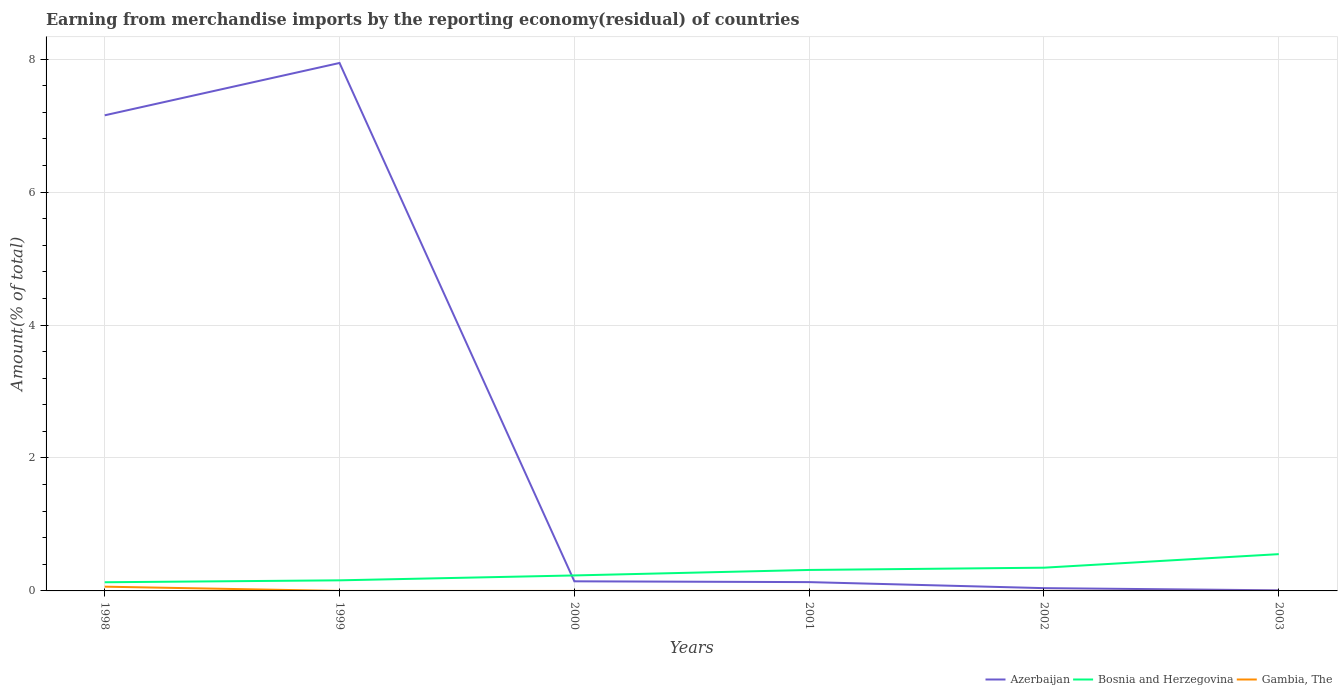How many different coloured lines are there?
Your answer should be compact. 3. Does the line corresponding to Azerbaijan intersect with the line corresponding to Bosnia and Herzegovina?
Offer a very short reply. Yes. Across all years, what is the maximum percentage of amount earned from merchandise imports in Azerbaijan?
Make the answer very short. 0.01. What is the total percentage of amount earned from merchandise imports in Gambia, The in the graph?
Your response must be concise. 8.75182859258105e-9. What is the difference between the highest and the second highest percentage of amount earned from merchandise imports in Gambia, The?
Your answer should be very brief. 0.06. What is the difference between the highest and the lowest percentage of amount earned from merchandise imports in Azerbaijan?
Ensure brevity in your answer.  2. Is the percentage of amount earned from merchandise imports in Azerbaijan strictly greater than the percentage of amount earned from merchandise imports in Gambia, The over the years?
Ensure brevity in your answer.  No. How many lines are there?
Your answer should be very brief. 3. What is the difference between two consecutive major ticks on the Y-axis?
Give a very brief answer. 2. Where does the legend appear in the graph?
Make the answer very short. Bottom right. How are the legend labels stacked?
Make the answer very short. Horizontal. What is the title of the graph?
Offer a terse response. Earning from merchandise imports by the reporting economy(residual) of countries. What is the label or title of the Y-axis?
Your answer should be compact. Amount(% of total). What is the Amount(% of total) of Azerbaijan in 1998?
Give a very brief answer. 7.16. What is the Amount(% of total) of Bosnia and Herzegovina in 1998?
Offer a terse response. 0.13. What is the Amount(% of total) of Gambia, The in 1998?
Provide a short and direct response. 0.06. What is the Amount(% of total) of Azerbaijan in 1999?
Provide a succinct answer. 7.94. What is the Amount(% of total) in Bosnia and Herzegovina in 1999?
Offer a very short reply. 0.16. What is the Amount(% of total) of Gambia, The in 1999?
Your response must be concise. 0. What is the Amount(% of total) of Azerbaijan in 2000?
Make the answer very short. 0.14. What is the Amount(% of total) of Bosnia and Herzegovina in 2000?
Provide a short and direct response. 0.23. What is the Amount(% of total) in Gambia, The in 2000?
Give a very brief answer. 1.18367928821763e-8. What is the Amount(% of total) in Azerbaijan in 2001?
Keep it short and to the point. 0.13. What is the Amount(% of total) of Bosnia and Herzegovina in 2001?
Offer a terse response. 0.32. What is the Amount(% of total) in Gambia, The in 2001?
Make the answer very short. 9.89188788859263e-9. What is the Amount(% of total) of Azerbaijan in 2002?
Your response must be concise. 0.04. What is the Amount(% of total) in Bosnia and Herzegovina in 2002?
Your answer should be very brief. 0.35. What is the Amount(% of total) in Gambia, The in 2002?
Your answer should be compact. 1.14005929601158e-9. What is the Amount(% of total) in Azerbaijan in 2003?
Make the answer very short. 0.01. What is the Amount(% of total) of Bosnia and Herzegovina in 2003?
Give a very brief answer. 0.55. Across all years, what is the maximum Amount(% of total) of Azerbaijan?
Make the answer very short. 7.94. Across all years, what is the maximum Amount(% of total) of Bosnia and Herzegovina?
Offer a very short reply. 0.55. Across all years, what is the maximum Amount(% of total) in Gambia, The?
Provide a short and direct response. 0.06. Across all years, what is the minimum Amount(% of total) of Azerbaijan?
Give a very brief answer. 0.01. Across all years, what is the minimum Amount(% of total) of Bosnia and Herzegovina?
Offer a terse response. 0.13. What is the total Amount(% of total) of Azerbaijan in the graph?
Give a very brief answer. 15.43. What is the total Amount(% of total) in Bosnia and Herzegovina in the graph?
Your answer should be very brief. 1.74. What is the total Amount(% of total) in Gambia, The in the graph?
Keep it short and to the point. 0.06. What is the difference between the Amount(% of total) in Azerbaijan in 1998 and that in 1999?
Ensure brevity in your answer.  -0.79. What is the difference between the Amount(% of total) in Bosnia and Herzegovina in 1998 and that in 1999?
Ensure brevity in your answer.  -0.03. What is the difference between the Amount(% of total) of Azerbaijan in 1998 and that in 2000?
Your answer should be compact. 7.01. What is the difference between the Amount(% of total) in Bosnia and Herzegovina in 1998 and that in 2000?
Make the answer very short. -0.1. What is the difference between the Amount(% of total) of Gambia, The in 1998 and that in 2000?
Your response must be concise. 0.06. What is the difference between the Amount(% of total) of Azerbaijan in 1998 and that in 2001?
Keep it short and to the point. 7.02. What is the difference between the Amount(% of total) in Bosnia and Herzegovina in 1998 and that in 2001?
Make the answer very short. -0.18. What is the difference between the Amount(% of total) of Gambia, The in 1998 and that in 2001?
Your answer should be very brief. 0.06. What is the difference between the Amount(% of total) of Azerbaijan in 1998 and that in 2002?
Provide a short and direct response. 7.11. What is the difference between the Amount(% of total) of Bosnia and Herzegovina in 1998 and that in 2002?
Ensure brevity in your answer.  -0.22. What is the difference between the Amount(% of total) in Gambia, The in 1998 and that in 2002?
Provide a succinct answer. 0.06. What is the difference between the Amount(% of total) of Azerbaijan in 1998 and that in 2003?
Offer a terse response. 7.15. What is the difference between the Amount(% of total) of Bosnia and Herzegovina in 1998 and that in 2003?
Offer a very short reply. -0.42. What is the difference between the Amount(% of total) in Azerbaijan in 1999 and that in 2000?
Keep it short and to the point. 7.8. What is the difference between the Amount(% of total) in Bosnia and Herzegovina in 1999 and that in 2000?
Provide a short and direct response. -0.07. What is the difference between the Amount(% of total) of Azerbaijan in 1999 and that in 2001?
Offer a terse response. 7.81. What is the difference between the Amount(% of total) of Bosnia and Herzegovina in 1999 and that in 2001?
Your response must be concise. -0.16. What is the difference between the Amount(% of total) of Azerbaijan in 1999 and that in 2002?
Provide a succinct answer. 7.9. What is the difference between the Amount(% of total) of Bosnia and Herzegovina in 1999 and that in 2002?
Ensure brevity in your answer.  -0.19. What is the difference between the Amount(% of total) in Azerbaijan in 1999 and that in 2003?
Your answer should be compact. 7.93. What is the difference between the Amount(% of total) in Bosnia and Herzegovina in 1999 and that in 2003?
Provide a short and direct response. -0.39. What is the difference between the Amount(% of total) of Azerbaijan in 2000 and that in 2001?
Keep it short and to the point. 0.01. What is the difference between the Amount(% of total) of Bosnia and Herzegovina in 2000 and that in 2001?
Give a very brief answer. -0.08. What is the difference between the Amount(% of total) of Gambia, The in 2000 and that in 2001?
Offer a terse response. 0. What is the difference between the Amount(% of total) in Azerbaijan in 2000 and that in 2002?
Your answer should be compact. 0.1. What is the difference between the Amount(% of total) in Bosnia and Herzegovina in 2000 and that in 2002?
Offer a terse response. -0.12. What is the difference between the Amount(% of total) of Gambia, The in 2000 and that in 2002?
Provide a succinct answer. 0. What is the difference between the Amount(% of total) of Azerbaijan in 2000 and that in 2003?
Your response must be concise. 0.14. What is the difference between the Amount(% of total) of Bosnia and Herzegovina in 2000 and that in 2003?
Provide a succinct answer. -0.32. What is the difference between the Amount(% of total) of Azerbaijan in 2001 and that in 2002?
Make the answer very short. 0.09. What is the difference between the Amount(% of total) in Bosnia and Herzegovina in 2001 and that in 2002?
Your answer should be very brief. -0.03. What is the difference between the Amount(% of total) of Gambia, The in 2001 and that in 2002?
Your answer should be compact. 0. What is the difference between the Amount(% of total) in Azerbaijan in 2001 and that in 2003?
Provide a short and direct response. 0.12. What is the difference between the Amount(% of total) of Bosnia and Herzegovina in 2001 and that in 2003?
Ensure brevity in your answer.  -0.24. What is the difference between the Amount(% of total) in Azerbaijan in 2002 and that in 2003?
Your answer should be very brief. 0.03. What is the difference between the Amount(% of total) of Bosnia and Herzegovina in 2002 and that in 2003?
Offer a terse response. -0.2. What is the difference between the Amount(% of total) in Azerbaijan in 1998 and the Amount(% of total) in Bosnia and Herzegovina in 1999?
Your answer should be compact. 7. What is the difference between the Amount(% of total) of Azerbaijan in 1998 and the Amount(% of total) of Bosnia and Herzegovina in 2000?
Your answer should be compact. 6.92. What is the difference between the Amount(% of total) of Azerbaijan in 1998 and the Amount(% of total) of Gambia, The in 2000?
Keep it short and to the point. 7.16. What is the difference between the Amount(% of total) in Bosnia and Herzegovina in 1998 and the Amount(% of total) in Gambia, The in 2000?
Your response must be concise. 0.13. What is the difference between the Amount(% of total) in Azerbaijan in 1998 and the Amount(% of total) in Bosnia and Herzegovina in 2001?
Keep it short and to the point. 6.84. What is the difference between the Amount(% of total) in Azerbaijan in 1998 and the Amount(% of total) in Gambia, The in 2001?
Your answer should be compact. 7.16. What is the difference between the Amount(% of total) in Bosnia and Herzegovina in 1998 and the Amount(% of total) in Gambia, The in 2001?
Your answer should be compact. 0.13. What is the difference between the Amount(% of total) in Azerbaijan in 1998 and the Amount(% of total) in Bosnia and Herzegovina in 2002?
Your answer should be very brief. 6.81. What is the difference between the Amount(% of total) of Azerbaijan in 1998 and the Amount(% of total) of Gambia, The in 2002?
Offer a terse response. 7.16. What is the difference between the Amount(% of total) in Bosnia and Herzegovina in 1998 and the Amount(% of total) in Gambia, The in 2002?
Your answer should be very brief. 0.13. What is the difference between the Amount(% of total) in Azerbaijan in 1998 and the Amount(% of total) in Bosnia and Herzegovina in 2003?
Provide a succinct answer. 6.6. What is the difference between the Amount(% of total) of Azerbaijan in 1999 and the Amount(% of total) of Bosnia and Herzegovina in 2000?
Provide a succinct answer. 7.71. What is the difference between the Amount(% of total) in Azerbaijan in 1999 and the Amount(% of total) in Gambia, The in 2000?
Keep it short and to the point. 7.94. What is the difference between the Amount(% of total) of Bosnia and Herzegovina in 1999 and the Amount(% of total) of Gambia, The in 2000?
Ensure brevity in your answer.  0.16. What is the difference between the Amount(% of total) of Azerbaijan in 1999 and the Amount(% of total) of Bosnia and Herzegovina in 2001?
Ensure brevity in your answer.  7.63. What is the difference between the Amount(% of total) in Azerbaijan in 1999 and the Amount(% of total) in Gambia, The in 2001?
Your answer should be compact. 7.94. What is the difference between the Amount(% of total) of Bosnia and Herzegovina in 1999 and the Amount(% of total) of Gambia, The in 2001?
Provide a short and direct response. 0.16. What is the difference between the Amount(% of total) of Azerbaijan in 1999 and the Amount(% of total) of Bosnia and Herzegovina in 2002?
Provide a short and direct response. 7.59. What is the difference between the Amount(% of total) of Azerbaijan in 1999 and the Amount(% of total) of Gambia, The in 2002?
Keep it short and to the point. 7.94. What is the difference between the Amount(% of total) of Bosnia and Herzegovina in 1999 and the Amount(% of total) of Gambia, The in 2002?
Keep it short and to the point. 0.16. What is the difference between the Amount(% of total) of Azerbaijan in 1999 and the Amount(% of total) of Bosnia and Herzegovina in 2003?
Make the answer very short. 7.39. What is the difference between the Amount(% of total) of Azerbaijan in 2000 and the Amount(% of total) of Bosnia and Herzegovina in 2001?
Your answer should be compact. -0.17. What is the difference between the Amount(% of total) of Azerbaijan in 2000 and the Amount(% of total) of Gambia, The in 2001?
Provide a short and direct response. 0.14. What is the difference between the Amount(% of total) in Bosnia and Herzegovina in 2000 and the Amount(% of total) in Gambia, The in 2001?
Provide a succinct answer. 0.23. What is the difference between the Amount(% of total) in Azerbaijan in 2000 and the Amount(% of total) in Bosnia and Herzegovina in 2002?
Offer a terse response. -0.21. What is the difference between the Amount(% of total) in Azerbaijan in 2000 and the Amount(% of total) in Gambia, The in 2002?
Ensure brevity in your answer.  0.14. What is the difference between the Amount(% of total) in Bosnia and Herzegovina in 2000 and the Amount(% of total) in Gambia, The in 2002?
Your response must be concise. 0.23. What is the difference between the Amount(% of total) of Azerbaijan in 2000 and the Amount(% of total) of Bosnia and Herzegovina in 2003?
Keep it short and to the point. -0.41. What is the difference between the Amount(% of total) in Azerbaijan in 2001 and the Amount(% of total) in Bosnia and Herzegovina in 2002?
Give a very brief answer. -0.22. What is the difference between the Amount(% of total) of Azerbaijan in 2001 and the Amount(% of total) of Gambia, The in 2002?
Your answer should be compact. 0.13. What is the difference between the Amount(% of total) in Bosnia and Herzegovina in 2001 and the Amount(% of total) in Gambia, The in 2002?
Make the answer very short. 0.32. What is the difference between the Amount(% of total) of Azerbaijan in 2001 and the Amount(% of total) of Bosnia and Herzegovina in 2003?
Your answer should be very brief. -0.42. What is the difference between the Amount(% of total) in Azerbaijan in 2002 and the Amount(% of total) in Bosnia and Herzegovina in 2003?
Ensure brevity in your answer.  -0.51. What is the average Amount(% of total) in Azerbaijan per year?
Keep it short and to the point. 2.57. What is the average Amount(% of total) in Bosnia and Herzegovina per year?
Offer a very short reply. 0.29. What is the average Amount(% of total) in Gambia, The per year?
Your answer should be compact. 0.01. In the year 1998, what is the difference between the Amount(% of total) of Azerbaijan and Amount(% of total) of Bosnia and Herzegovina?
Give a very brief answer. 7.02. In the year 1998, what is the difference between the Amount(% of total) of Azerbaijan and Amount(% of total) of Gambia, The?
Offer a terse response. 7.09. In the year 1998, what is the difference between the Amount(% of total) in Bosnia and Herzegovina and Amount(% of total) in Gambia, The?
Your response must be concise. 0.07. In the year 1999, what is the difference between the Amount(% of total) in Azerbaijan and Amount(% of total) in Bosnia and Herzegovina?
Keep it short and to the point. 7.78. In the year 2000, what is the difference between the Amount(% of total) of Azerbaijan and Amount(% of total) of Bosnia and Herzegovina?
Make the answer very short. -0.09. In the year 2000, what is the difference between the Amount(% of total) in Azerbaijan and Amount(% of total) in Gambia, The?
Your answer should be very brief. 0.14. In the year 2000, what is the difference between the Amount(% of total) of Bosnia and Herzegovina and Amount(% of total) of Gambia, The?
Offer a terse response. 0.23. In the year 2001, what is the difference between the Amount(% of total) of Azerbaijan and Amount(% of total) of Bosnia and Herzegovina?
Keep it short and to the point. -0.18. In the year 2001, what is the difference between the Amount(% of total) of Azerbaijan and Amount(% of total) of Gambia, The?
Provide a short and direct response. 0.13. In the year 2001, what is the difference between the Amount(% of total) in Bosnia and Herzegovina and Amount(% of total) in Gambia, The?
Offer a terse response. 0.32. In the year 2002, what is the difference between the Amount(% of total) of Azerbaijan and Amount(% of total) of Bosnia and Herzegovina?
Your answer should be very brief. -0.31. In the year 2002, what is the difference between the Amount(% of total) in Azerbaijan and Amount(% of total) in Gambia, The?
Provide a short and direct response. 0.04. In the year 2002, what is the difference between the Amount(% of total) in Bosnia and Herzegovina and Amount(% of total) in Gambia, The?
Offer a terse response. 0.35. In the year 2003, what is the difference between the Amount(% of total) in Azerbaijan and Amount(% of total) in Bosnia and Herzegovina?
Offer a terse response. -0.54. What is the ratio of the Amount(% of total) of Azerbaijan in 1998 to that in 1999?
Your response must be concise. 0.9. What is the ratio of the Amount(% of total) of Bosnia and Herzegovina in 1998 to that in 1999?
Ensure brevity in your answer.  0.82. What is the ratio of the Amount(% of total) of Azerbaijan in 1998 to that in 2000?
Offer a terse response. 49.53. What is the ratio of the Amount(% of total) of Bosnia and Herzegovina in 1998 to that in 2000?
Offer a terse response. 0.56. What is the ratio of the Amount(% of total) of Gambia, The in 1998 to that in 2000?
Provide a succinct answer. 5.40e+06. What is the ratio of the Amount(% of total) in Azerbaijan in 1998 to that in 2001?
Offer a very short reply. 53.98. What is the ratio of the Amount(% of total) of Bosnia and Herzegovina in 1998 to that in 2001?
Your response must be concise. 0.41. What is the ratio of the Amount(% of total) of Gambia, The in 1998 to that in 2001?
Offer a very short reply. 6.46e+06. What is the ratio of the Amount(% of total) in Azerbaijan in 1998 to that in 2002?
Make the answer very short. 170.82. What is the ratio of the Amount(% of total) in Bosnia and Herzegovina in 1998 to that in 2002?
Make the answer very short. 0.37. What is the ratio of the Amount(% of total) in Gambia, The in 1998 to that in 2002?
Keep it short and to the point. 5.61e+07. What is the ratio of the Amount(% of total) in Azerbaijan in 1998 to that in 2003?
Offer a terse response. 806.69. What is the ratio of the Amount(% of total) of Bosnia and Herzegovina in 1998 to that in 2003?
Offer a very short reply. 0.24. What is the ratio of the Amount(% of total) in Azerbaijan in 1999 to that in 2000?
Give a very brief answer. 54.98. What is the ratio of the Amount(% of total) in Bosnia and Herzegovina in 1999 to that in 2000?
Provide a succinct answer. 0.68. What is the ratio of the Amount(% of total) in Azerbaijan in 1999 to that in 2001?
Keep it short and to the point. 59.92. What is the ratio of the Amount(% of total) of Bosnia and Herzegovina in 1999 to that in 2001?
Provide a succinct answer. 0.51. What is the ratio of the Amount(% of total) of Azerbaijan in 1999 to that in 2002?
Keep it short and to the point. 189.62. What is the ratio of the Amount(% of total) of Bosnia and Herzegovina in 1999 to that in 2002?
Your response must be concise. 0.46. What is the ratio of the Amount(% of total) of Azerbaijan in 1999 to that in 2003?
Give a very brief answer. 895.44. What is the ratio of the Amount(% of total) in Bosnia and Herzegovina in 1999 to that in 2003?
Keep it short and to the point. 0.29. What is the ratio of the Amount(% of total) in Azerbaijan in 2000 to that in 2001?
Make the answer very short. 1.09. What is the ratio of the Amount(% of total) of Bosnia and Herzegovina in 2000 to that in 2001?
Give a very brief answer. 0.74. What is the ratio of the Amount(% of total) of Gambia, The in 2000 to that in 2001?
Your response must be concise. 1.2. What is the ratio of the Amount(% of total) of Azerbaijan in 2000 to that in 2002?
Offer a very short reply. 3.45. What is the ratio of the Amount(% of total) in Bosnia and Herzegovina in 2000 to that in 2002?
Provide a succinct answer. 0.67. What is the ratio of the Amount(% of total) of Gambia, The in 2000 to that in 2002?
Give a very brief answer. 10.38. What is the ratio of the Amount(% of total) in Azerbaijan in 2000 to that in 2003?
Make the answer very short. 16.29. What is the ratio of the Amount(% of total) in Bosnia and Herzegovina in 2000 to that in 2003?
Your answer should be compact. 0.42. What is the ratio of the Amount(% of total) in Azerbaijan in 2001 to that in 2002?
Offer a very short reply. 3.16. What is the ratio of the Amount(% of total) of Bosnia and Herzegovina in 2001 to that in 2002?
Your response must be concise. 0.9. What is the ratio of the Amount(% of total) in Gambia, The in 2001 to that in 2002?
Your response must be concise. 8.68. What is the ratio of the Amount(% of total) of Azerbaijan in 2001 to that in 2003?
Ensure brevity in your answer.  14.94. What is the ratio of the Amount(% of total) of Bosnia and Herzegovina in 2001 to that in 2003?
Ensure brevity in your answer.  0.57. What is the ratio of the Amount(% of total) of Azerbaijan in 2002 to that in 2003?
Give a very brief answer. 4.72. What is the ratio of the Amount(% of total) of Bosnia and Herzegovina in 2002 to that in 2003?
Keep it short and to the point. 0.63. What is the difference between the highest and the second highest Amount(% of total) in Azerbaijan?
Give a very brief answer. 0.79. What is the difference between the highest and the second highest Amount(% of total) of Bosnia and Herzegovina?
Your answer should be very brief. 0.2. What is the difference between the highest and the second highest Amount(% of total) of Gambia, The?
Your answer should be compact. 0.06. What is the difference between the highest and the lowest Amount(% of total) of Azerbaijan?
Provide a succinct answer. 7.93. What is the difference between the highest and the lowest Amount(% of total) in Bosnia and Herzegovina?
Your answer should be compact. 0.42. What is the difference between the highest and the lowest Amount(% of total) of Gambia, The?
Provide a short and direct response. 0.06. 